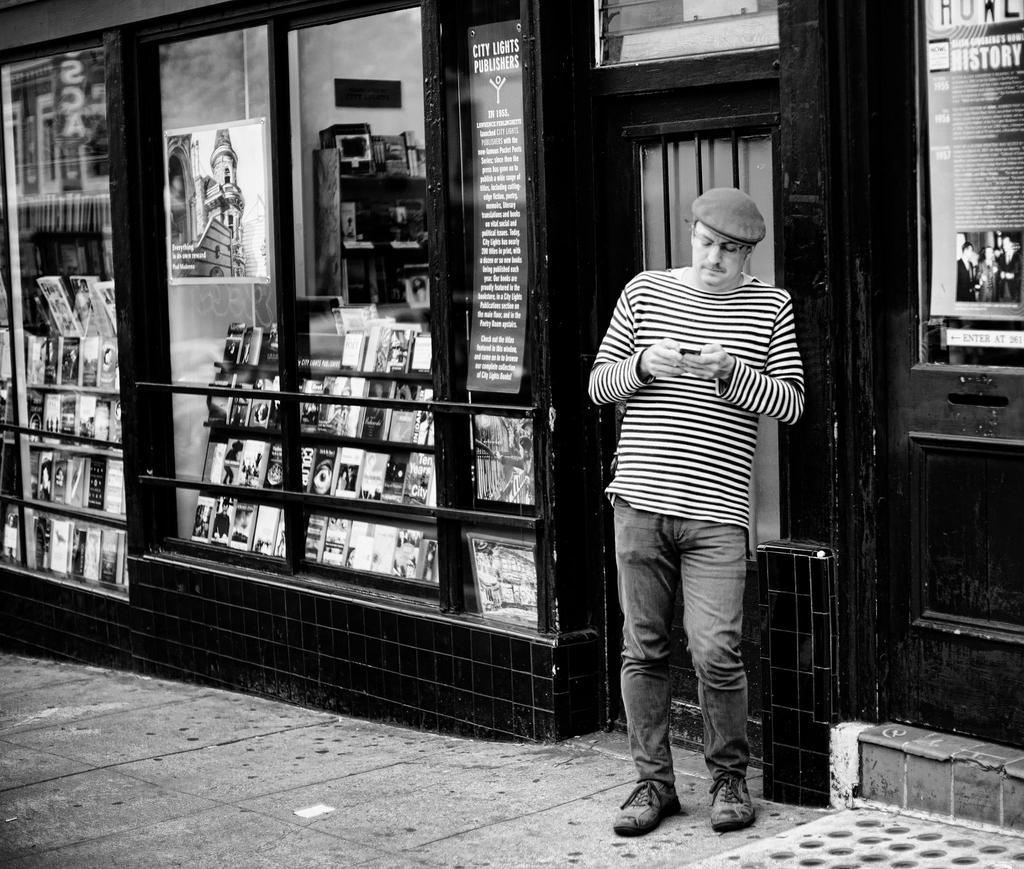What is the main subject of the image? There is a man in the image. What is the man doing in the image? The man is standing in the image. What is the man holding in the image? The man is holding an object in the image. What type of items can be seen in the image besides the man? There are books and posters on a glass surface visible in the image. What type of underwear is the man wearing in the image? There is no information about the man's underwear in the image, so it cannot be determined. Where is the park located in the image? There is no park present in the image. 